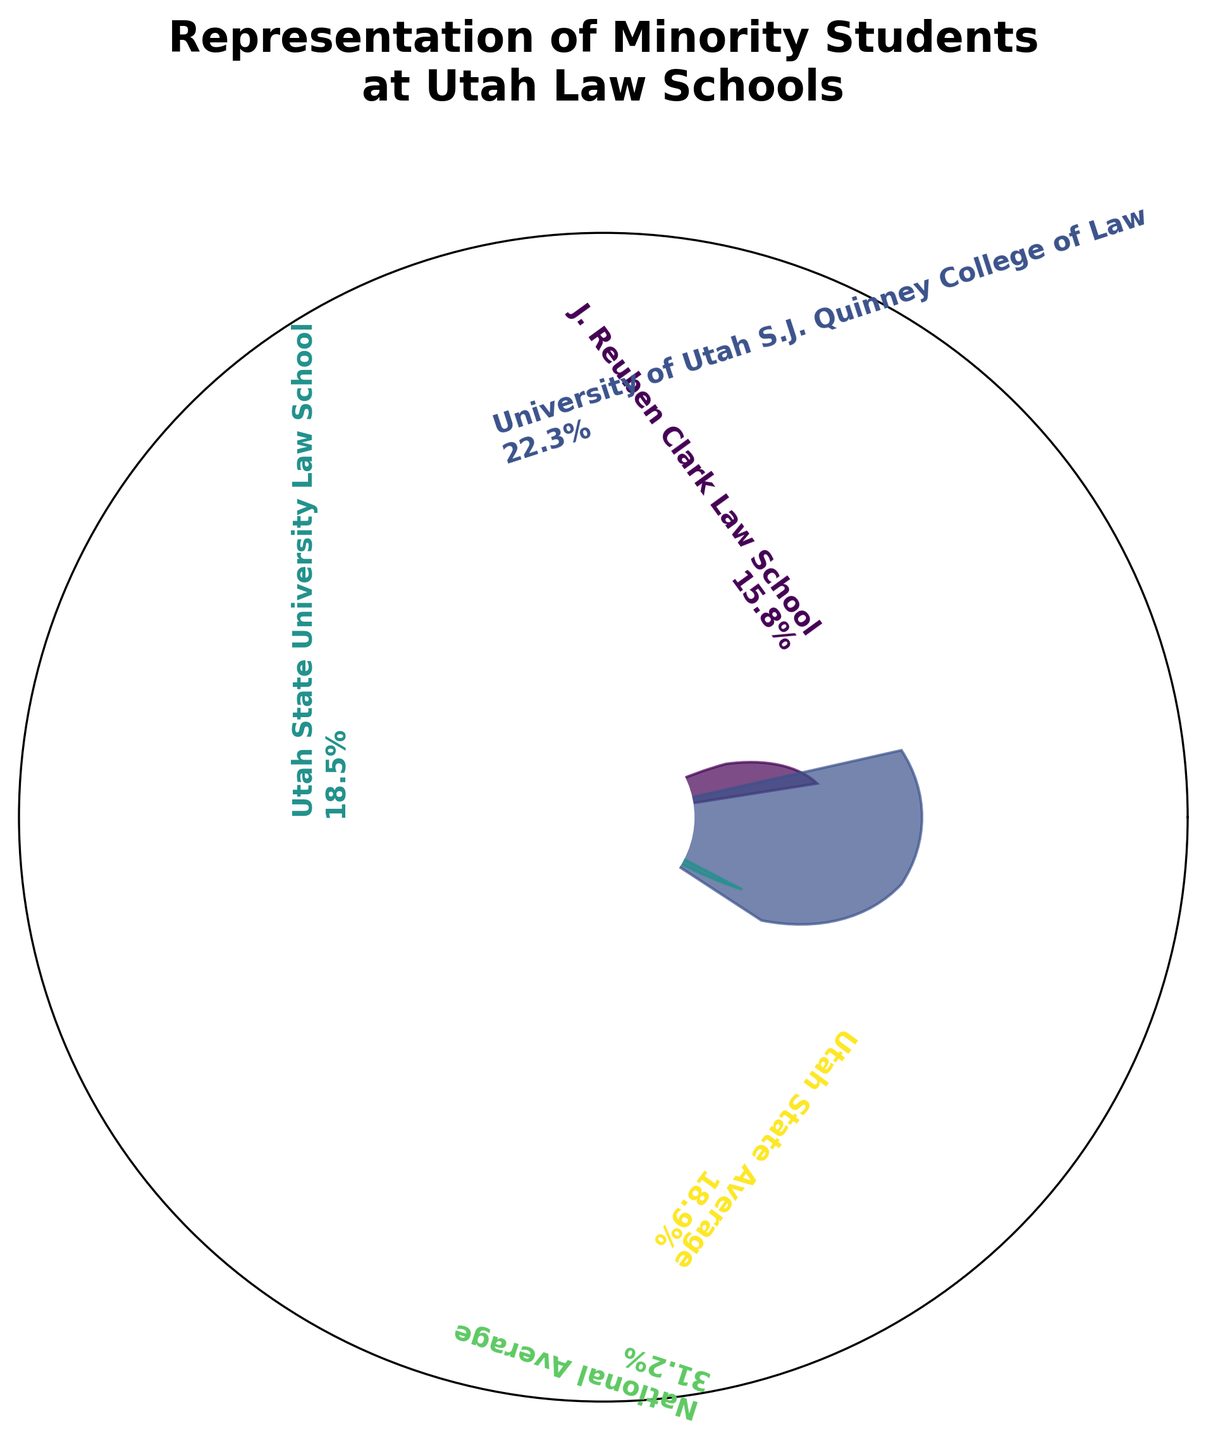What's the title of the plot? The title is usually found at the top of the plot. In this plot, it states "Representation of Minority Students at Utah Law Schools."
Answer: Representation of Minority Students at Utah Law Schools Which law school has the highest percentage of minority students? By looking at the lengths of the wedges and the percentage labels, we can see that "University of Utah S.J. Quinney College of Law" has the highest percentage of minority students.
Answer: University of Utah S.J. Quinney College of Law How does the representation of minority students at J. Reuben Clark Law School compare to the state average? The state average is represented by one of the wedges, labeled "Utah State Average." J. Reuben Clark Law School’s percentage is 15.8%, while the state average is 18.9%, making J. Reuben Clark Law School’s percentage lower.
Answer: Lower What is the difference in minority representation between the J. Reuben Clark Law School and the national average? Subtract the percentage of minority students at J. Reuben Clark Law School (15.8%) from the national average (31.2%). Calculation: 31.2 - 15.8 = 15.4
Answer: 15.4 Which schools have a higher percentage of minority students than J. Reuben Clark Law School? Compare the percentages. "University of Utah S.J. Quinney College of Law" (22.3%) and "Utah State University Law School" (18.5%) are both higher than 15.8%.
Answer: University of Utah S.J. Quinney College of Law, Utah State University Law School What’s the average minority representation percentage across the three law schools listed? Add the percentages (15.8, 22.3, and 18.5) and divide by the number of schools (3). Calculation: (15.8 + 22.3 + 18.5) / 3 ≈ 18.87
Answer: 18.87 Which color representation corresponds to the J. Reuben Clark Law School? Examine the plot to identify the wedge associated with J. Reuben Clark Law School and note its color.
Answer: The color specific to J. Reuben Clark Law School as seen on the plot (usually not readily answerable without an actual image, assumedly greenish in context) Is the minority student representation at Utah State University Law School closer to the J. Reuben Clark Law School or the state average? Compute the absolute differences between Utah State University Law School's percentage (18.5%) and both J. Reuben Clark Law School (15.8%) and the state average (18.9%). Differences are: 18.5 - 15.8 = 2.7 and 18.9 - 18.5 = 0.4. It is closer to the state average.
Answer: Closer to the state average What is the combined percentage representation of minority students for all Utah schools listed? Sum the percentages of the three schools listed (15.8, 22.3, and 18.5). Calculation: 15.8 + 22.3 + 18.5 = 56.6%
Answer: 56.6 Which school is closest to the state average in terms of minority representation? Compare the percentages of the schools with the state average (18.9%). Utah State University Law School (18.5%) is the closest.
Answer: Utah State University Law School 